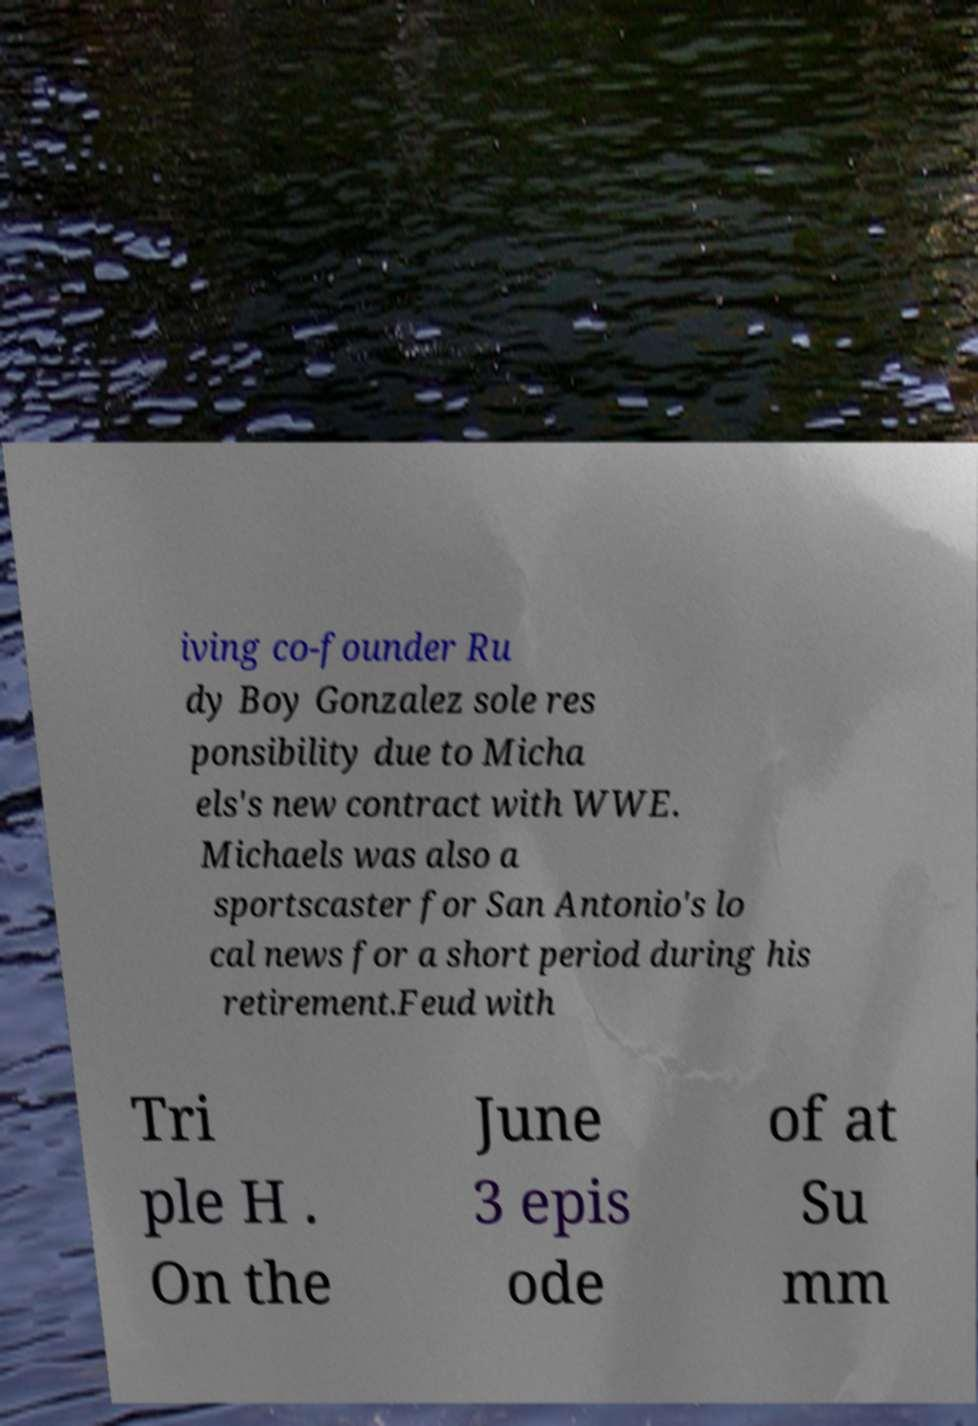I need the written content from this picture converted into text. Can you do that? iving co-founder Ru dy Boy Gonzalez sole res ponsibility due to Micha els's new contract with WWE. Michaels was also a sportscaster for San Antonio's lo cal news for a short period during his retirement.Feud with Tri ple H . On the June 3 epis ode of at Su mm 